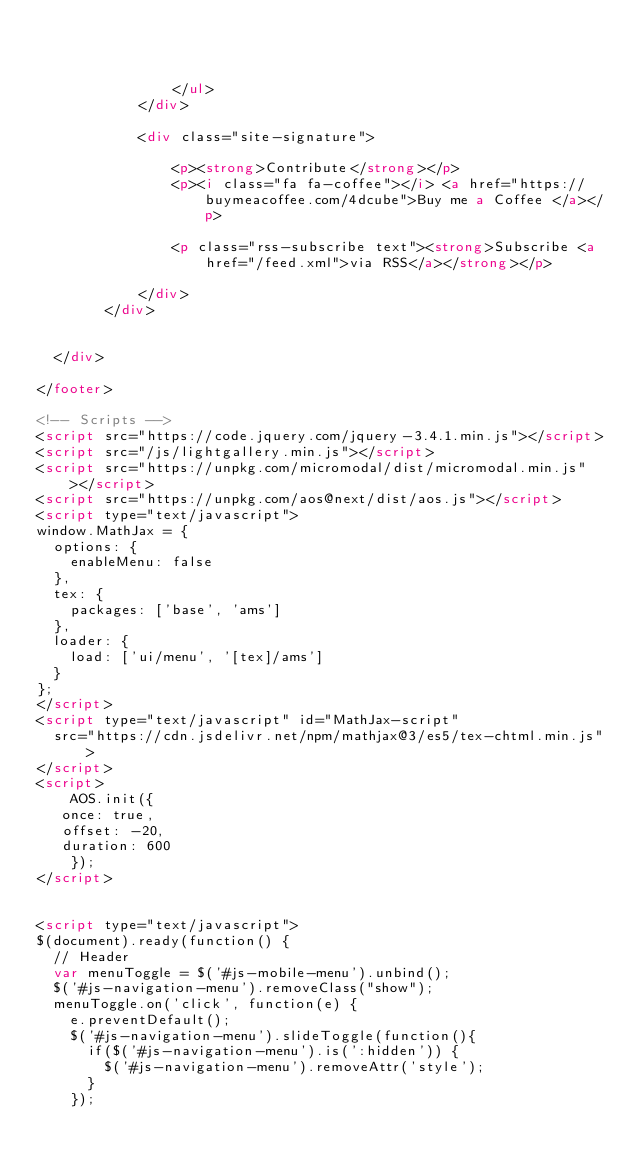Convert code to text. <code><loc_0><loc_0><loc_500><loc_500><_HTML_>	


				</ul>
			</div>

			<div class="site-signature">
				
				<p><strong>Contribute</strong></p>
				<p><i class="fa fa-coffee"></i> <a href="https://buymeacoffee.com/4dcube">Buy me a Coffee </a></p>
				
				<p class="rss-subscribe text"><strong>Subscribe <a href="/feed.xml">via RSS</a></strong></p>
				
			</div>
		</div>


  </div>

</footer>

<!-- Scripts -->
<script src="https://code.jquery.com/jquery-3.4.1.min.js"></script>
<script src="/js/lightgallery.min.js"></script>
<script src="https://unpkg.com/micromodal/dist/micromodal.min.js"></script>
<script src="https://unpkg.com/aos@next/dist/aos.js"></script>
<script type="text/javascript">
window.MathJax = {
  options: {
    enableMenu: false
  },
  tex: {
    packages: ['base', 'ams']
  },
  loader: {
    load: ['ui/menu', '[tex]/ams']
  }
};
</script>
<script type="text/javascript" id="MathJax-script"
  src="https://cdn.jsdelivr.net/npm/mathjax@3/es5/tex-chtml.min.js">
</script>
<script>
	AOS.init({
   once: true,
   offset: -20,
   duration: 600
	});
</script>


<script type="text/javascript">
$(document).ready(function() {
  // Header
  var menuToggle = $('#js-mobile-menu').unbind();
  $('#js-navigation-menu').removeClass("show");
  menuToggle.on('click', function(e) {
    e.preventDefault();
    $('#js-navigation-menu').slideToggle(function(){
      if($('#js-navigation-menu').is(':hidden')) {
        $('#js-navigation-menu').removeAttr('style');
      }
    });</code> 